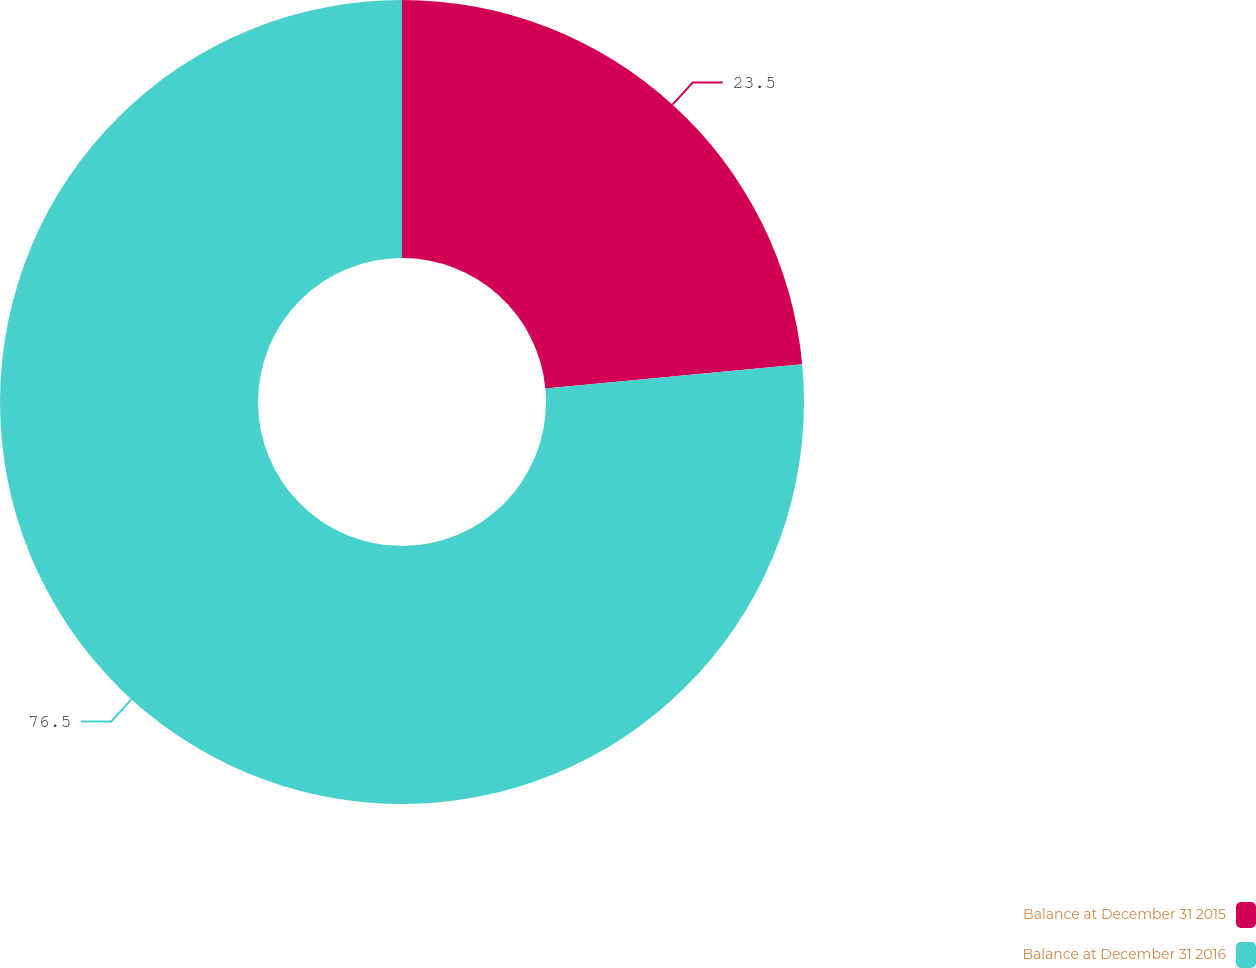Convert chart. <chart><loc_0><loc_0><loc_500><loc_500><pie_chart><fcel>Balance at December 31 2015<fcel>Balance at December 31 2016<nl><fcel>23.5%<fcel>76.5%<nl></chart> 